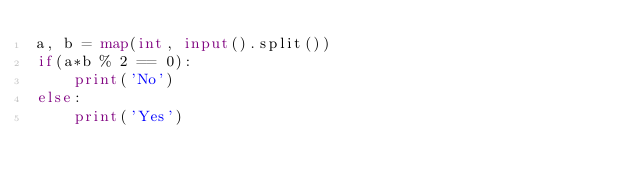<code> <loc_0><loc_0><loc_500><loc_500><_Python_>a, b = map(int, input().split())
if(a*b % 2 == 0):
    print('No')
else:
    print('Yes')
</code> 